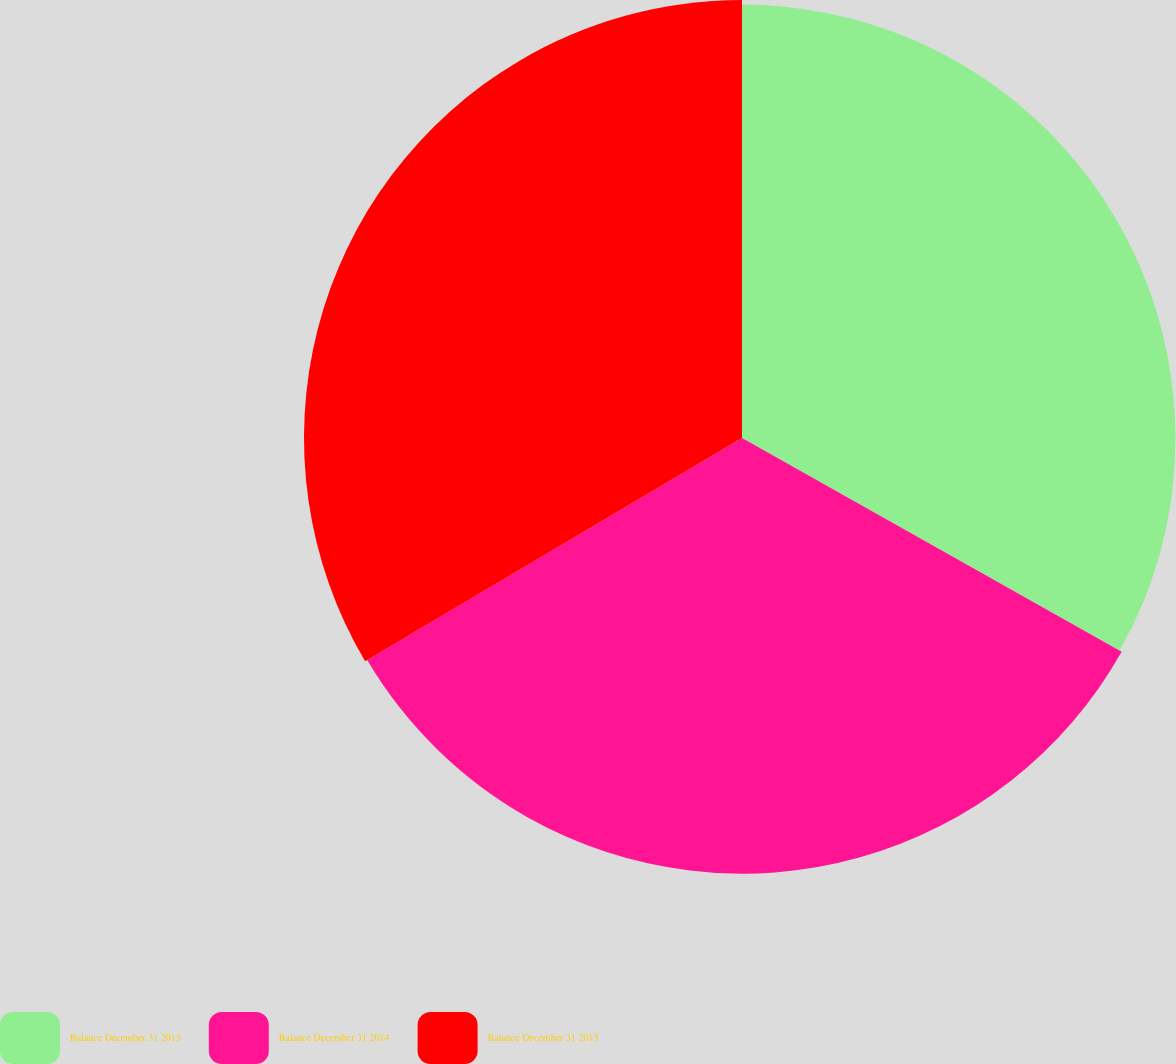Convert chart to OTSL. <chart><loc_0><loc_0><loc_500><loc_500><pie_chart><fcel>Balance December 31 2013<fcel>Balance December 31 2014<fcel>Balance December 31 2015<nl><fcel>33.16%<fcel>33.33%<fcel>33.51%<nl></chart> 